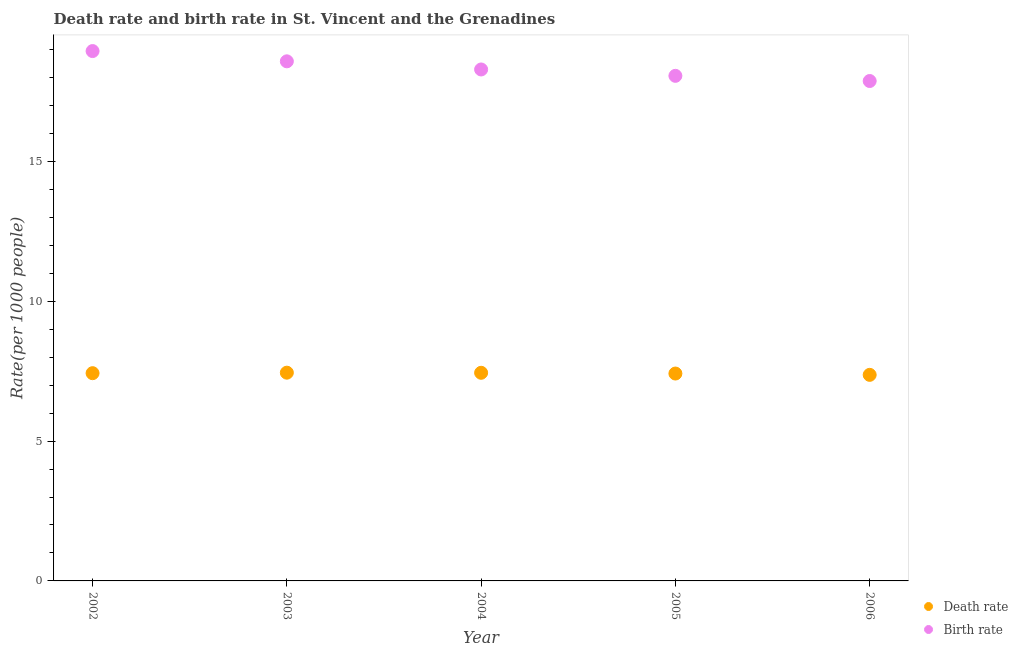How many different coloured dotlines are there?
Make the answer very short. 2. What is the death rate in 2006?
Ensure brevity in your answer.  7.37. Across all years, what is the maximum birth rate?
Your response must be concise. 18.95. Across all years, what is the minimum birth rate?
Make the answer very short. 17.88. What is the total death rate in the graph?
Your response must be concise. 37.1. What is the difference between the birth rate in 2003 and that in 2005?
Provide a short and direct response. 0.52. What is the difference between the birth rate in 2006 and the death rate in 2005?
Offer a terse response. 10.46. What is the average death rate per year?
Provide a succinct answer. 7.42. In the year 2003, what is the difference between the death rate and birth rate?
Keep it short and to the point. -11.13. What is the ratio of the birth rate in 2002 to that in 2005?
Make the answer very short. 1.05. Is the death rate in 2003 less than that in 2004?
Offer a terse response. No. What is the difference between the highest and the second highest death rate?
Your response must be concise. 0. What is the difference between the highest and the lowest death rate?
Your answer should be very brief. 0.08. In how many years, is the death rate greater than the average death rate taken over all years?
Offer a terse response. 3. Does the birth rate monotonically increase over the years?
Offer a very short reply. No. Is the birth rate strictly greater than the death rate over the years?
Offer a terse response. Yes. Is the birth rate strictly less than the death rate over the years?
Provide a short and direct response. No. How many dotlines are there?
Your response must be concise. 2. What is the difference between two consecutive major ticks on the Y-axis?
Provide a short and direct response. 5. Are the values on the major ticks of Y-axis written in scientific E-notation?
Keep it short and to the point. No. Does the graph contain any zero values?
Offer a very short reply. No. Does the graph contain grids?
Your answer should be compact. No. Where does the legend appear in the graph?
Provide a succinct answer. Bottom right. How are the legend labels stacked?
Make the answer very short. Vertical. What is the title of the graph?
Give a very brief answer. Death rate and birth rate in St. Vincent and the Grenadines. Does "Crop" appear as one of the legend labels in the graph?
Provide a short and direct response. No. What is the label or title of the Y-axis?
Offer a terse response. Rate(per 1000 people). What is the Rate(per 1000 people) of Death rate in 2002?
Offer a terse response. 7.43. What is the Rate(per 1000 people) in Birth rate in 2002?
Give a very brief answer. 18.95. What is the Rate(per 1000 people) of Death rate in 2003?
Give a very brief answer. 7.45. What is the Rate(per 1000 people) in Birth rate in 2003?
Provide a succinct answer. 18.58. What is the Rate(per 1000 people) of Death rate in 2004?
Your response must be concise. 7.44. What is the Rate(per 1000 people) of Birth rate in 2004?
Your answer should be very brief. 18.29. What is the Rate(per 1000 people) of Death rate in 2005?
Your answer should be compact. 7.42. What is the Rate(per 1000 people) in Birth rate in 2005?
Your answer should be compact. 18.06. What is the Rate(per 1000 people) in Death rate in 2006?
Keep it short and to the point. 7.37. What is the Rate(per 1000 people) in Birth rate in 2006?
Your answer should be very brief. 17.88. Across all years, what is the maximum Rate(per 1000 people) of Death rate?
Ensure brevity in your answer.  7.45. Across all years, what is the maximum Rate(per 1000 people) of Birth rate?
Provide a short and direct response. 18.95. Across all years, what is the minimum Rate(per 1000 people) of Death rate?
Offer a very short reply. 7.37. Across all years, what is the minimum Rate(per 1000 people) in Birth rate?
Offer a terse response. 17.88. What is the total Rate(per 1000 people) of Death rate in the graph?
Provide a short and direct response. 37.1. What is the total Rate(per 1000 people) in Birth rate in the graph?
Make the answer very short. 91.76. What is the difference between the Rate(per 1000 people) of Death rate in 2002 and that in 2003?
Keep it short and to the point. -0.02. What is the difference between the Rate(per 1000 people) of Birth rate in 2002 and that in 2003?
Keep it short and to the point. 0.37. What is the difference between the Rate(per 1000 people) in Death rate in 2002 and that in 2004?
Provide a succinct answer. -0.01. What is the difference between the Rate(per 1000 people) in Birth rate in 2002 and that in 2004?
Offer a very short reply. 0.66. What is the difference between the Rate(per 1000 people) of Death rate in 2002 and that in 2005?
Your response must be concise. 0.01. What is the difference between the Rate(per 1000 people) in Birth rate in 2002 and that in 2005?
Ensure brevity in your answer.  0.89. What is the difference between the Rate(per 1000 people) of Death rate in 2002 and that in 2006?
Your response must be concise. 0.06. What is the difference between the Rate(per 1000 people) in Birth rate in 2002 and that in 2006?
Keep it short and to the point. 1.07. What is the difference between the Rate(per 1000 people) of Death rate in 2003 and that in 2004?
Keep it short and to the point. 0. What is the difference between the Rate(per 1000 people) of Birth rate in 2003 and that in 2004?
Ensure brevity in your answer.  0.29. What is the difference between the Rate(per 1000 people) of Death rate in 2003 and that in 2005?
Make the answer very short. 0.03. What is the difference between the Rate(per 1000 people) of Birth rate in 2003 and that in 2005?
Provide a succinct answer. 0.52. What is the difference between the Rate(per 1000 people) of Death rate in 2003 and that in 2006?
Your answer should be very brief. 0.08. What is the difference between the Rate(per 1000 people) in Birth rate in 2003 and that in 2006?
Provide a succinct answer. 0.7. What is the difference between the Rate(per 1000 people) in Death rate in 2004 and that in 2005?
Your answer should be compact. 0.03. What is the difference between the Rate(per 1000 people) of Birth rate in 2004 and that in 2005?
Your answer should be very brief. 0.23. What is the difference between the Rate(per 1000 people) of Death rate in 2004 and that in 2006?
Provide a succinct answer. 0.07. What is the difference between the Rate(per 1000 people) of Birth rate in 2004 and that in 2006?
Offer a very short reply. 0.41. What is the difference between the Rate(per 1000 people) of Death rate in 2005 and that in 2006?
Your answer should be compact. 0.05. What is the difference between the Rate(per 1000 people) of Birth rate in 2005 and that in 2006?
Your answer should be very brief. 0.18. What is the difference between the Rate(per 1000 people) of Death rate in 2002 and the Rate(per 1000 people) of Birth rate in 2003?
Your answer should be very brief. -11.15. What is the difference between the Rate(per 1000 people) of Death rate in 2002 and the Rate(per 1000 people) of Birth rate in 2004?
Provide a short and direct response. -10.86. What is the difference between the Rate(per 1000 people) of Death rate in 2002 and the Rate(per 1000 people) of Birth rate in 2005?
Make the answer very short. -10.63. What is the difference between the Rate(per 1000 people) of Death rate in 2002 and the Rate(per 1000 people) of Birth rate in 2006?
Your answer should be compact. -10.45. What is the difference between the Rate(per 1000 people) in Death rate in 2003 and the Rate(per 1000 people) in Birth rate in 2004?
Keep it short and to the point. -10.84. What is the difference between the Rate(per 1000 people) in Death rate in 2003 and the Rate(per 1000 people) in Birth rate in 2005?
Make the answer very short. -10.62. What is the difference between the Rate(per 1000 people) in Death rate in 2003 and the Rate(per 1000 people) in Birth rate in 2006?
Ensure brevity in your answer.  -10.43. What is the difference between the Rate(per 1000 people) of Death rate in 2004 and the Rate(per 1000 people) of Birth rate in 2005?
Offer a terse response. -10.62. What is the difference between the Rate(per 1000 people) in Death rate in 2004 and the Rate(per 1000 people) in Birth rate in 2006?
Your response must be concise. -10.43. What is the difference between the Rate(per 1000 people) of Death rate in 2005 and the Rate(per 1000 people) of Birth rate in 2006?
Your response must be concise. -10.46. What is the average Rate(per 1000 people) in Death rate per year?
Ensure brevity in your answer.  7.42. What is the average Rate(per 1000 people) of Birth rate per year?
Provide a succinct answer. 18.35. In the year 2002, what is the difference between the Rate(per 1000 people) of Death rate and Rate(per 1000 people) of Birth rate?
Provide a short and direct response. -11.52. In the year 2003, what is the difference between the Rate(per 1000 people) in Death rate and Rate(per 1000 people) in Birth rate?
Your answer should be compact. -11.13. In the year 2004, what is the difference between the Rate(per 1000 people) in Death rate and Rate(per 1000 people) in Birth rate?
Keep it short and to the point. -10.85. In the year 2005, what is the difference between the Rate(per 1000 people) in Death rate and Rate(per 1000 people) in Birth rate?
Ensure brevity in your answer.  -10.65. In the year 2006, what is the difference between the Rate(per 1000 people) of Death rate and Rate(per 1000 people) of Birth rate?
Provide a short and direct response. -10.51. What is the ratio of the Rate(per 1000 people) of Birth rate in 2002 to that in 2003?
Give a very brief answer. 1.02. What is the ratio of the Rate(per 1000 people) in Death rate in 2002 to that in 2004?
Your answer should be very brief. 1. What is the ratio of the Rate(per 1000 people) of Birth rate in 2002 to that in 2004?
Offer a terse response. 1.04. What is the ratio of the Rate(per 1000 people) in Death rate in 2002 to that in 2005?
Keep it short and to the point. 1. What is the ratio of the Rate(per 1000 people) in Birth rate in 2002 to that in 2005?
Ensure brevity in your answer.  1.05. What is the ratio of the Rate(per 1000 people) in Death rate in 2002 to that in 2006?
Keep it short and to the point. 1.01. What is the ratio of the Rate(per 1000 people) in Birth rate in 2002 to that in 2006?
Your answer should be very brief. 1.06. What is the ratio of the Rate(per 1000 people) of Birth rate in 2003 to that in 2004?
Provide a succinct answer. 1.02. What is the ratio of the Rate(per 1000 people) in Birth rate in 2003 to that in 2005?
Provide a short and direct response. 1.03. What is the ratio of the Rate(per 1000 people) in Death rate in 2003 to that in 2006?
Make the answer very short. 1.01. What is the ratio of the Rate(per 1000 people) of Birth rate in 2003 to that in 2006?
Keep it short and to the point. 1.04. What is the ratio of the Rate(per 1000 people) in Birth rate in 2004 to that in 2005?
Give a very brief answer. 1.01. What is the ratio of the Rate(per 1000 people) of Birth rate in 2004 to that in 2006?
Your answer should be compact. 1.02. What is the ratio of the Rate(per 1000 people) in Death rate in 2005 to that in 2006?
Offer a terse response. 1.01. What is the ratio of the Rate(per 1000 people) in Birth rate in 2005 to that in 2006?
Keep it short and to the point. 1.01. What is the difference between the highest and the second highest Rate(per 1000 people) of Death rate?
Ensure brevity in your answer.  0. What is the difference between the highest and the second highest Rate(per 1000 people) in Birth rate?
Offer a very short reply. 0.37. What is the difference between the highest and the lowest Rate(per 1000 people) of Death rate?
Ensure brevity in your answer.  0.08. What is the difference between the highest and the lowest Rate(per 1000 people) of Birth rate?
Provide a succinct answer. 1.07. 